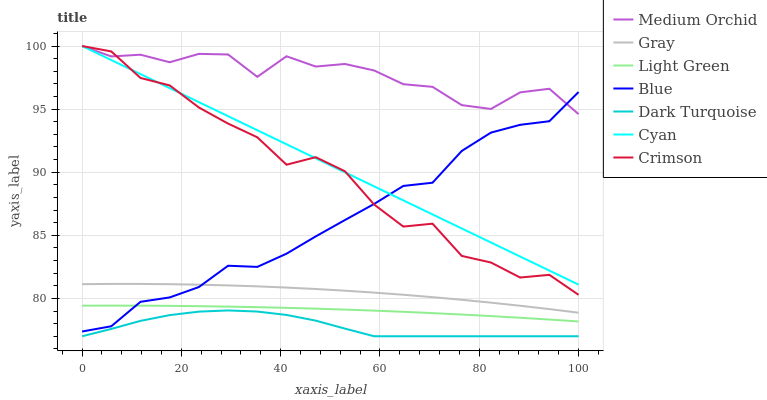Does Dark Turquoise have the minimum area under the curve?
Answer yes or no. Yes. Does Medium Orchid have the maximum area under the curve?
Answer yes or no. Yes. Does Gray have the minimum area under the curve?
Answer yes or no. No. Does Gray have the maximum area under the curve?
Answer yes or no. No. Is Cyan the smoothest?
Answer yes or no. Yes. Is Crimson the roughest?
Answer yes or no. Yes. Is Gray the smoothest?
Answer yes or no. No. Is Gray the roughest?
Answer yes or no. No. Does Dark Turquoise have the lowest value?
Answer yes or no. Yes. Does Gray have the lowest value?
Answer yes or no. No. Does Cyan have the highest value?
Answer yes or no. Yes. Does Gray have the highest value?
Answer yes or no. No. Is Gray less than Crimson?
Answer yes or no. Yes. Is Blue greater than Dark Turquoise?
Answer yes or no. Yes. Does Blue intersect Medium Orchid?
Answer yes or no. Yes. Is Blue less than Medium Orchid?
Answer yes or no. No. Is Blue greater than Medium Orchid?
Answer yes or no. No. Does Gray intersect Crimson?
Answer yes or no. No. 